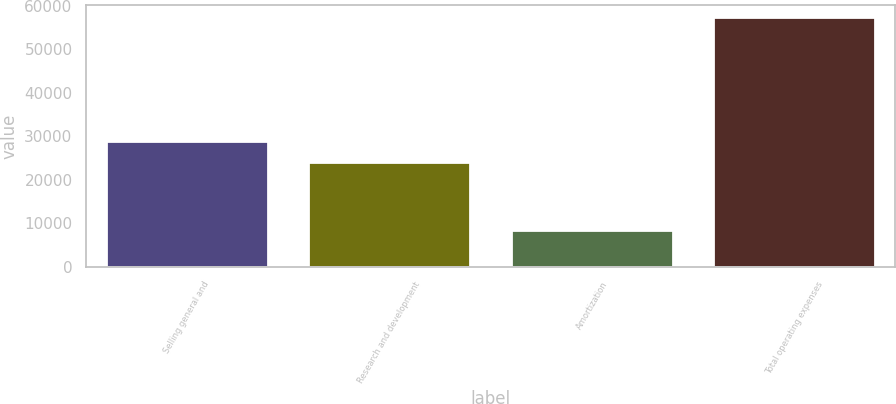<chart> <loc_0><loc_0><loc_500><loc_500><bar_chart><fcel>Selling general and<fcel>Research and development<fcel>Amortization<fcel>Total operating expenses<nl><fcel>28989.9<fcel>24098<fcel>8454<fcel>57373<nl></chart> 